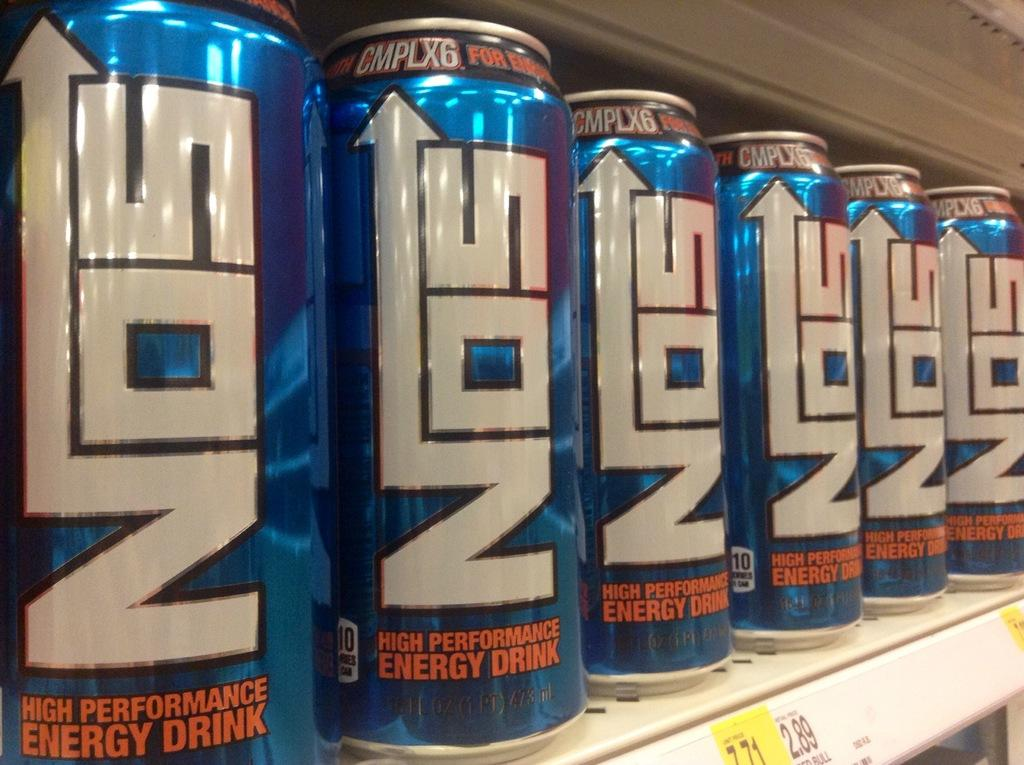<image>
Present a compact description of the photo's key features. Several cans of NOS high performance energy drink are side by side on a shelf. 